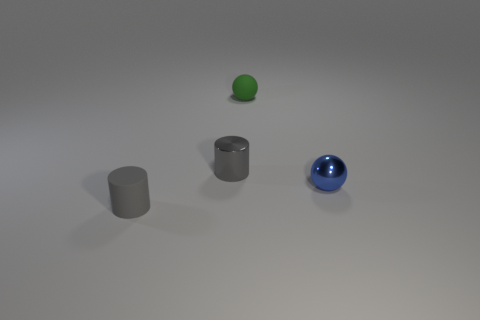There is a tiny green rubber sphere; what number of blue metal things are on the left side of it? There are no blue metal objects to the left side of the tiny green rubber sphere. To its right, there is a single blue metal sphere. 